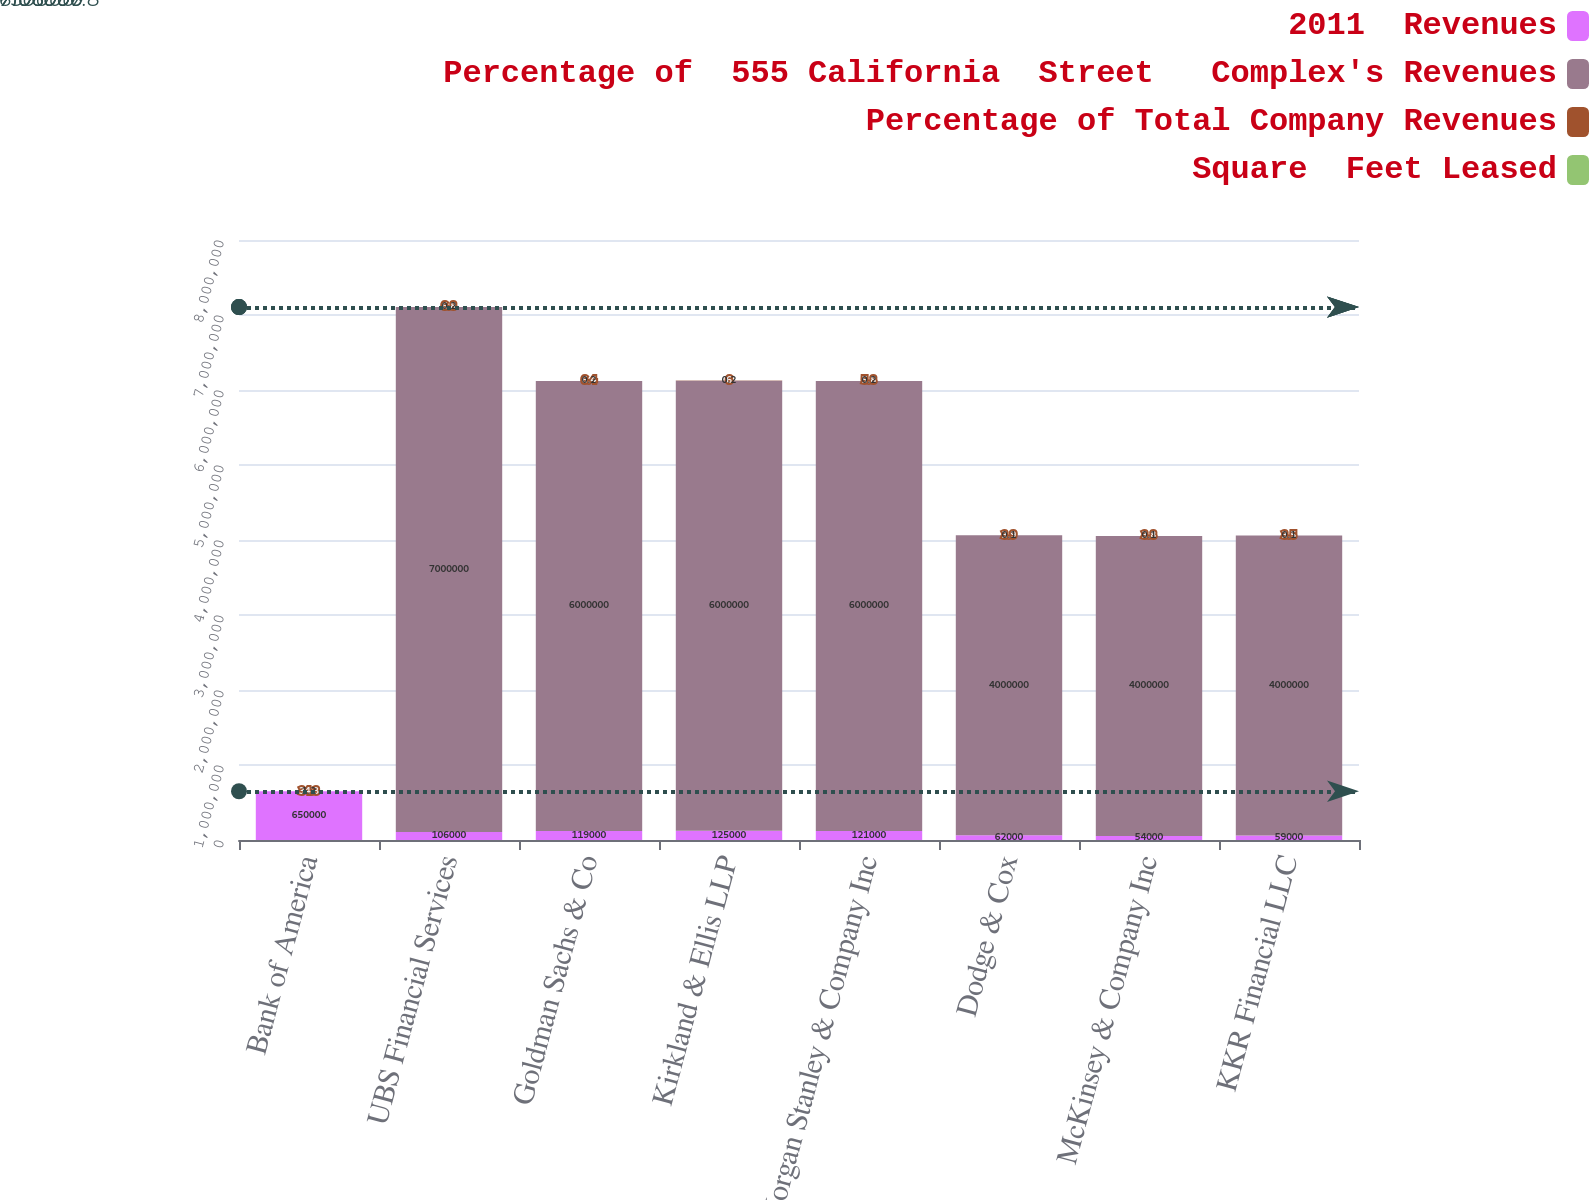Convert chart to OTSL. <chart><loc_0><loc_0><loc_500><loc_500><stacked_bar_chart><ecel><fcel>Bank of America<fcel>UBS Financial Services<fcel>Goldman Sachs & Co<fcel>Kirkland & Ellis LLP<fcel>Morgan Stanley & Company Inc<fcel>Dodge & Cox<fcel>McKinsey & Company Inc<fcel>KKR Financial LLC<nl><fcel>2011  Revenues<fcel>650000<fcel>106000<fcel>119000<fcel>125000<fcel>121000<fcel>62000<fcel>54000<fcel>59000<nl><fcel>Percentage of  555 California  Street   Complex's Revenues<fcel>34.3<fcel>7e+06<fcel>6e+06<fcel>6e+06<fcel>6e+06<fcel>4e+06<fcel>4e+06<fcel>4e+06<nl><fcel>Percentage of Total Company Revenues<fcel>34.3<fcel>6.8<fcel>6.4<fcel>6<fcel>5.8<fcel>3.9<fcel>3.8<fcel>3.5<nl><fcel>Square  Feet Leased<fcel>1.2<fcel>0.2<fcel>0.2<fcel>0.2<fcel>0.2<fcel>0.1<fcel>0.1<fcel>0.1<nl></chart> 